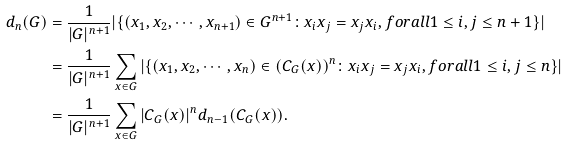Convert formula to latex. <formula><loc_0><loc_0><loc_500><loc_500>d _ { n } ( G ) & = \frac { 1 } { | G | ^ { n + 1 } } | \{ ( x _ { 1 } , x _ { 2 } , \cdots , x _ { n + 1 } ) \in G ^ { n + 1 } \colon x _ { i } x _ { j } = x _ { j } x _ { i } , f o r a l l 1 \leq i , j \leq n + 1 \} | \\ & = \frac { 1 } { | G | ^ { n + 1 } } \sum _ { x \in G } | \{ ( x _ { 1 } , x _ { 2 } , \cdots , x _ { n } ) \in ( C _ { G } ( x ) ) ^ { n } \colon x _ { i } x _ { j } = x _ { j } x _ { i } , f o r a l l 1 \leq i , j \leq n \} | \\ & = \frac { 1 } { | G | ^ { n + 1 } } \sum _ { x \in G } | C _ { G } ( x ) | ^ { n } { d _ { n - 1 } ( C _ { G } ( x ) ) } .</formula> 